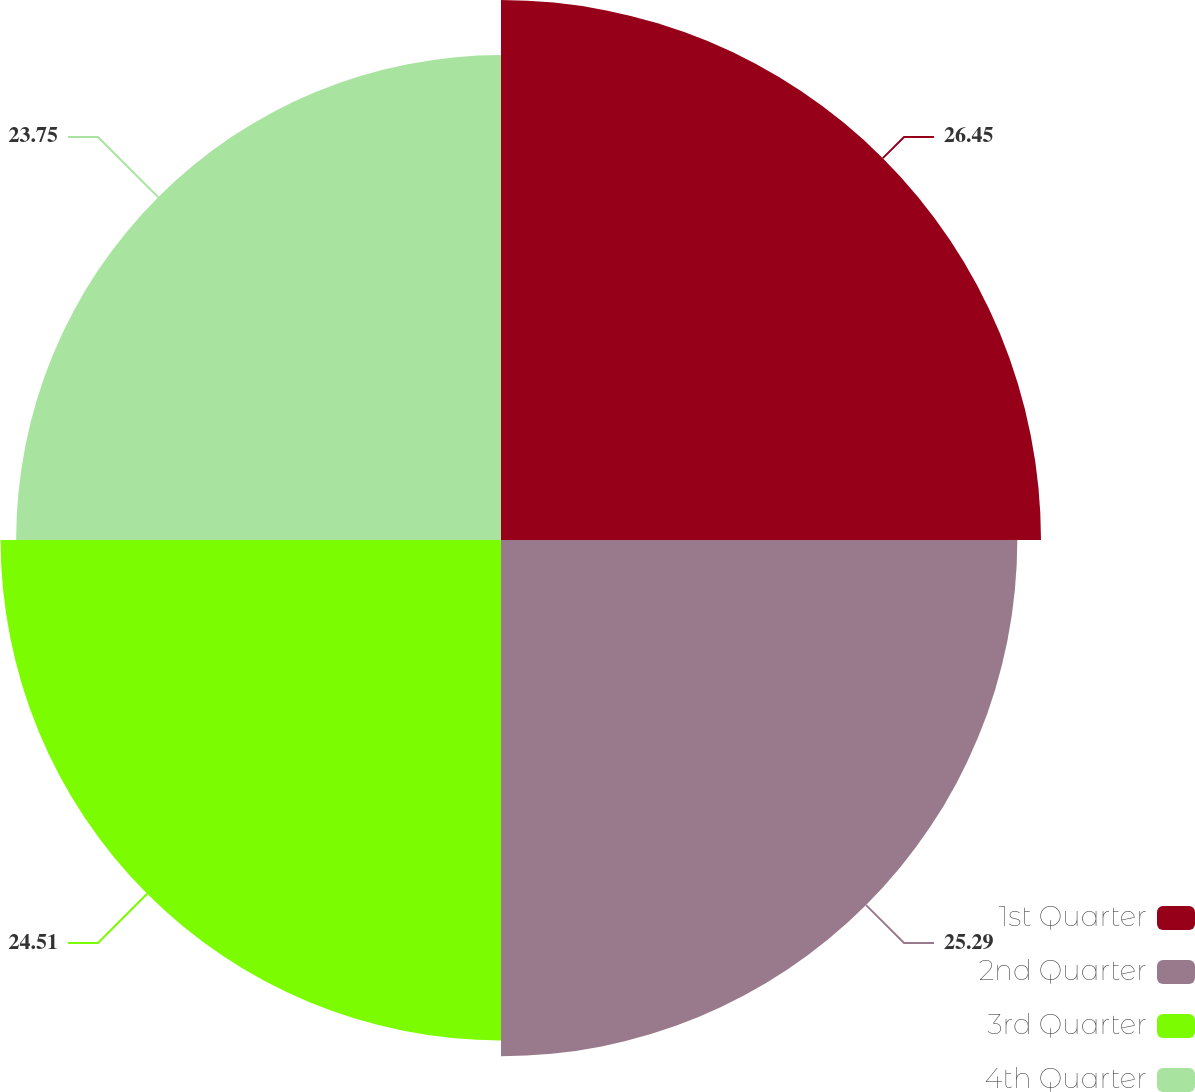Convert chart to OTSL. <chart><loc_0><loc_0><loc_500><loc_500><pie_chart><fcel>1st Quarter<fcel>2nd Quarter<fcel>3rd Quarter<fcel>4th Quarter<nl><fcel>26.45%<fcel>25.29%<fcel>24.51%<fcel>23.75%<nl></chart> 